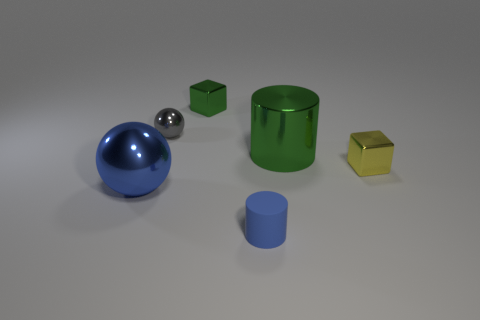The other metal thing that is the same shape as the small gray thing is what color?
Offer a very short reply. Blue. Is there anything else that is the same shape as the big green object?
Your answer should be very brief. Yes. Is the shape of the yellow object the same as the blue object that is to the left of the tiny gray metallic sphere?
Ensure brevity in your answer.  No. What is the material of the yellow cube?
Your answer should be very brief. Metal. What is the size of the green thing that is the same shape as the small blue rubber object?
Provide a succinct answer. Large. How many other objects are there of the same material as the large green object?
Provide a short and direct response. 4. Do the tiny yellow cube and the cube that is to the left of the blue rubber object have the same material?
Give a very brief answer. Yes. Is the number of shiny objects on the left side of the big blue ball less than the number of green metallic blocks that are on the right side of the tiny yellow metallic cube?
Provide a short and direct response. No. What color is the small metal cube that is behind the tiny yellow shiny cube?
Offer a terse response. Green. How many other objects are the same color as the big ball?
Ensure brevity in your answer.  1. 